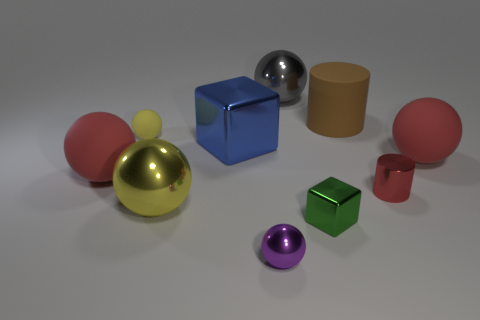Are there any small purple things made of the same material as the red cylinder?
Make the answer very short. Yes. What number of metal spheres are both in front of the small green cube and behind the large brown rubber object?
Offer a terse response. 0. Is the number of red matte objects that are on the right side of the small yellow rubber sphere less than the number of spheres that are behind the small red cylinder?
Offer a very short reply. Yes. Is the shape of the blue thing the same as the large gray object?
Your answer should be compact. No. How many other objects are the same size as the green metal object?
Keep it short and to the point. 3. How many objects are tiny balls behind the green metallic block or big spheres on the right side of the small red cylinder?
Make the answer very short. 2. What number of green objects are the same shape as the tiny red thing?
Offer a very short reply. 0. What material is the red object that is both right of the large brown matte cylinder and behind the tiny metallic cylinder?
Your answer should be very brief. Rubber. There is a large yellow object; how many large spheres are on the left side of it?
Offer a terse response. 1. What number of small red cubes are there?
Give a very brief answer. 0. 